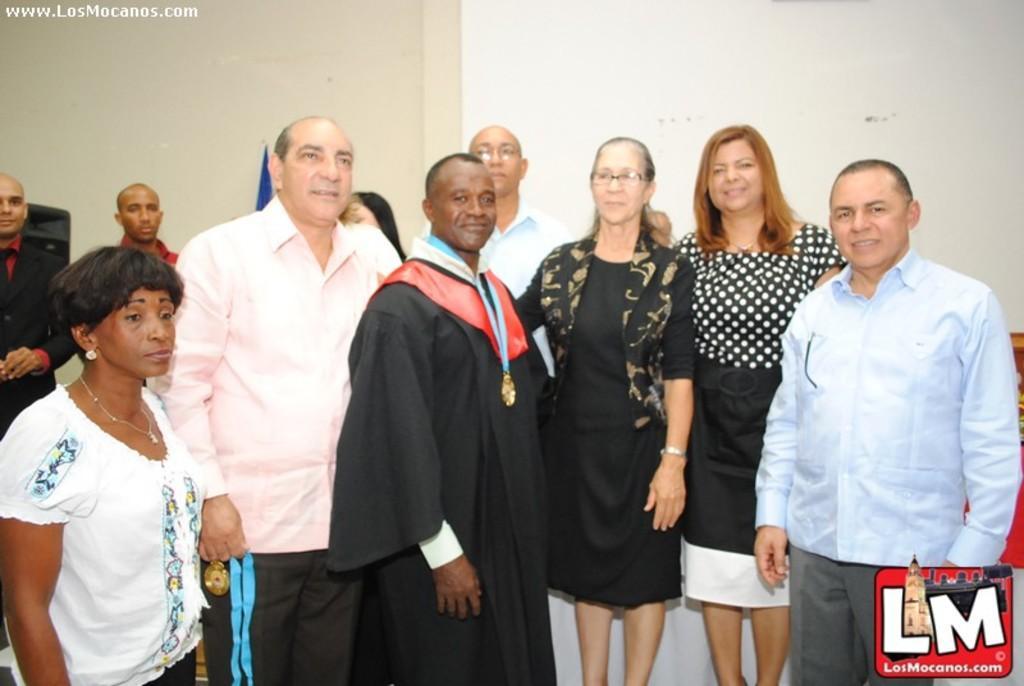Could you give a brief overview of what you see in this image? In this image we can see a few people, on of them is holding a medal, also we cam see the wall, and there are text on the image. 